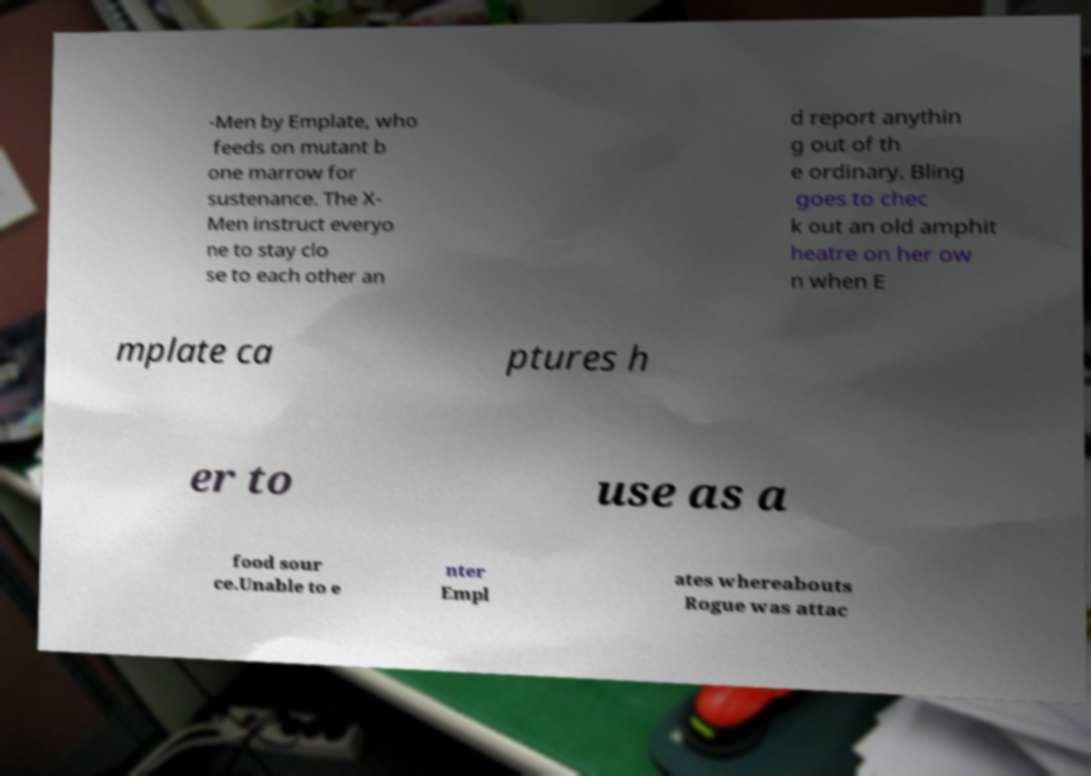Please read and relay the text visible in this image. What does it say? -Men by Emplate, who feeds on mutant b one marrow for sustenance. The X- Men instruct everyo ne to stay clo se to each other an d report anythin g out of th e ordinary. Bling goes to chec k out an old amphit heatre on her ow n when E mplate ca ptures h er to use as a food sour ce.Unable to e nter Empl ates whereabouts Rogue was attac 